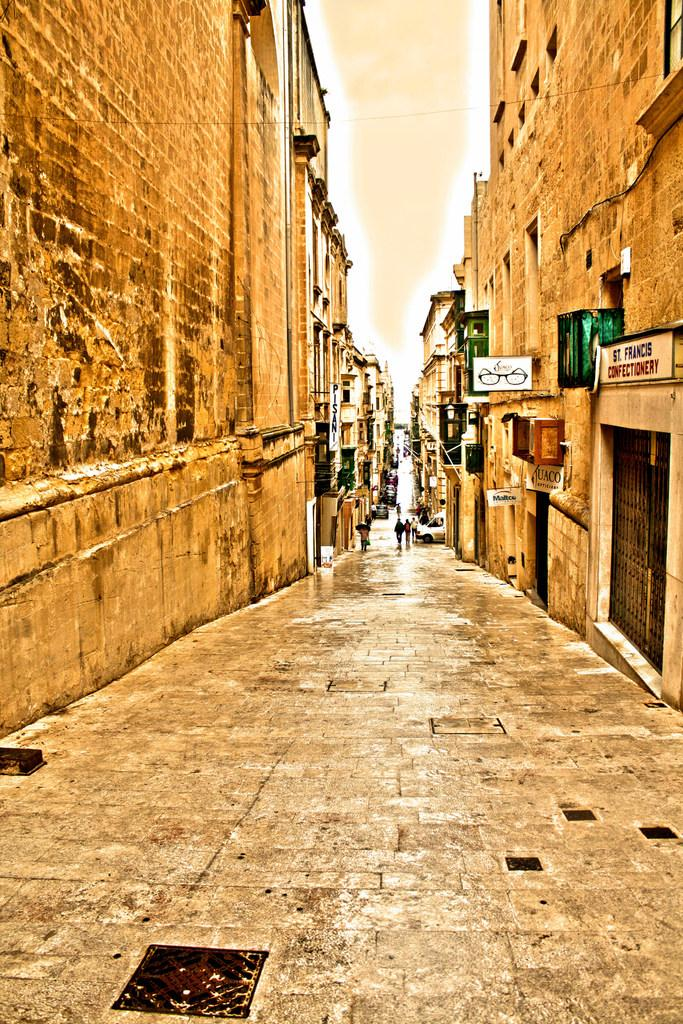What is the main setting of the image? There is a street in the image. What are the people in the street doing? There are groups of people walking in the street. What else can be seen moving in the street? There are vehicles moving in the street. What can be seen on both sides of the street? There are buildings on the left side and the right side of the image. What type of acoustics can be heard in the image? There is no specific sound or acoustics mentioned in the image, so it cannot be determined. 